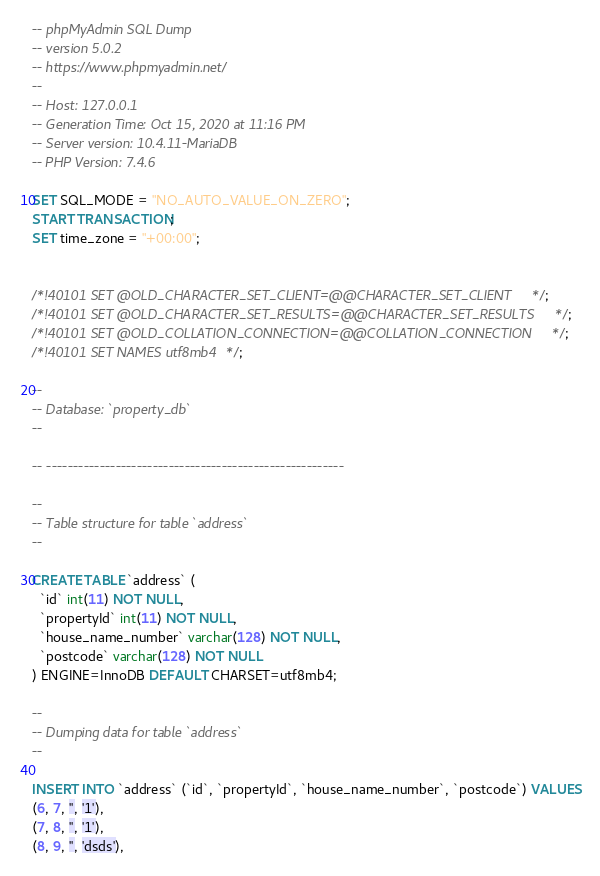<code> <loc_0><loc_0><loc_500><loc_500><_SQL_>-- phpMyAdmin SQL Dump
-- version 5.0.2
-- https://www.phpmyadmin.net/
--
-- Host: 127.0.0.1
-- Generation Time: Oct 15, 2020 at 11:16 PM
-- Server version: 10.4.11-MariaDB
-- PHP Version: 7.4.6

SET SQL_MODE = "NO_AUTO_VALUE_ON_ZERO";
START TRANSACTION;
SET time_zone = "+00:00";


/*!40101 SET @OLD_CHARACTER_SET_CLIENT=@@CHARACTER_SET_CLIENT */;
/*!40101 SET @OLD_CHARACTER_SET_RESULTS=@@CHARACTER_SET_RESULTS */;
/*!40101 SET @OLD_COLLATION_CONNECTION=@@COLLATION_CONNECTION */;
/*!40101 SET NAMES utf8mb4 */;

--
-- Database: `property_db`
--

-- --------------------------------------------------------

--
-- Table structure for table `address`
--

CREATE TABLE `address` (
  `id` int(11) NOT NULL,
  `propertyId` int(11) NOT NULL,
  `house_name_number` varchar(128) NOT NULL,
  `postcode` varchar(128) NOT NULL
) ENGINE=InnoDB DEFAULT CHARSET=utf8mb4;

--
-- Dumping data for table `address`
--

INSERT INTO `address` (`id`, `propertyId`, `house_name_number`, `postcode`) VALUES
(6, 7, '', '1'),
(7, 8, '', '1'),
(8, 9, '', 'dsds'),</code> 